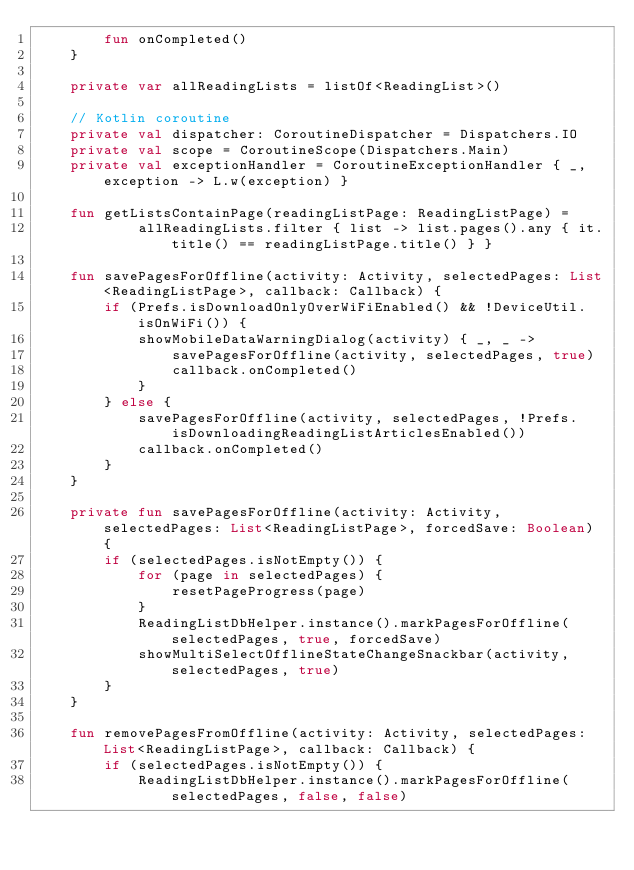<code> <loc_0><loc_0><loc_500><loc_500><_Kotlin_>        fun onCompleted()
    }

    private var allReadingLists = listOf<ReadingList>()

    // Kotlin coroutine
    private val dispatcher: CoroutineDispatcher = Dispatchers.IO
    private val scope = CoroutineScope(Dispatchers.Main)
    private val exceptionHandler = CoroutineExceptionHandler { _, exception -> L.w(exception) }

    fun getListsContainPage(readingListPage: ReadingListPage) =
            allReadingLists.filter { list -> list.pages().any { it.title() == readingListPage.title() } }

    fun savePagesForOffline(activity: Activity, selectedPages: List<ReadingListPage>, callback: Callback) {
        if (Prefs.isDownloadOnlyOverWiFiEnabled() && !DeviceUtil.isOnWiFi()) {
            showMobileDataWarningDialog(activity) { _, _ ->
                savePagesForOffline(activity, selectedPages, true)
                callback.onCompleted()
            }
        } else {
            savePagesForOffline(activity, selectedPages, !Prefs.isDownloadingReadingListArticlesEnabled())
            callback.onCompleted()
        }
    }

    private fun savePagesForOffline(activity: Activity, selectedPages: List<ReadingListPage>, forcedSave: Boolean) {
        if (selectedPages.isNotEmpty()) {
            for (page in selectedPages) {
                resetPageProgress(page)
            }
            ReadingListDbHelper.instance().markPagesForOffline(selectedPages, true, forcedSave)
            showMultiSelectOfflineStateChangeSnackbar(activity, selectedPages, true)
        }
    }

    fun removePagesFromOffline(activity: Activity, selectedPages: List<ReadingListPage>, callback: Callback) {
        if (selectedPages.isNotEmpty()) {
            ReadingListDbHelper.instance().markPagesForOffline(selectedPages, false, false)</code> 